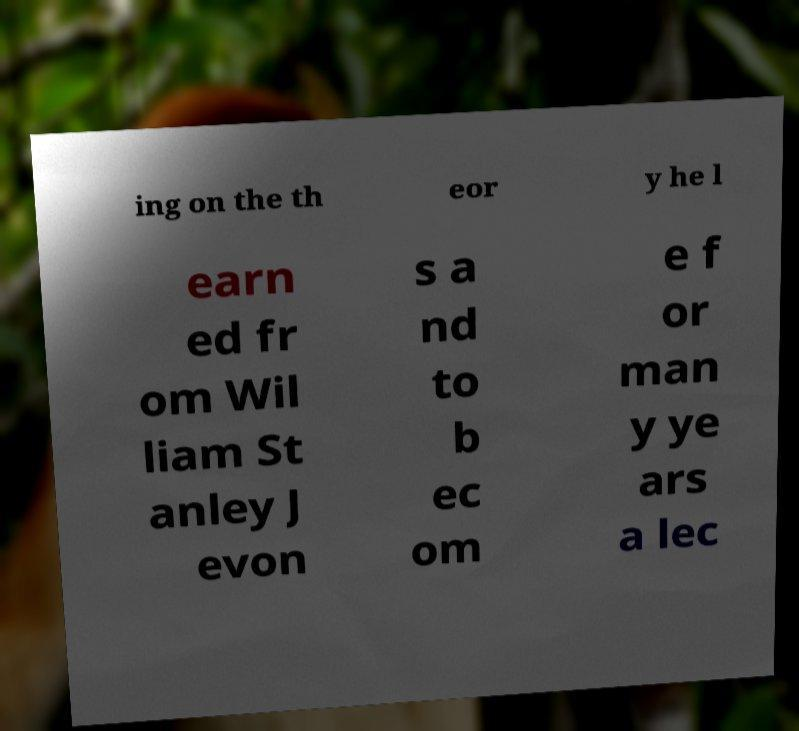Please read and relay the text visible in this image. What does it say? ing on the th eor y he l earn ed fr om Wil liam St anley J evon s a nd to b ec om e f or man y ye ars a lec 